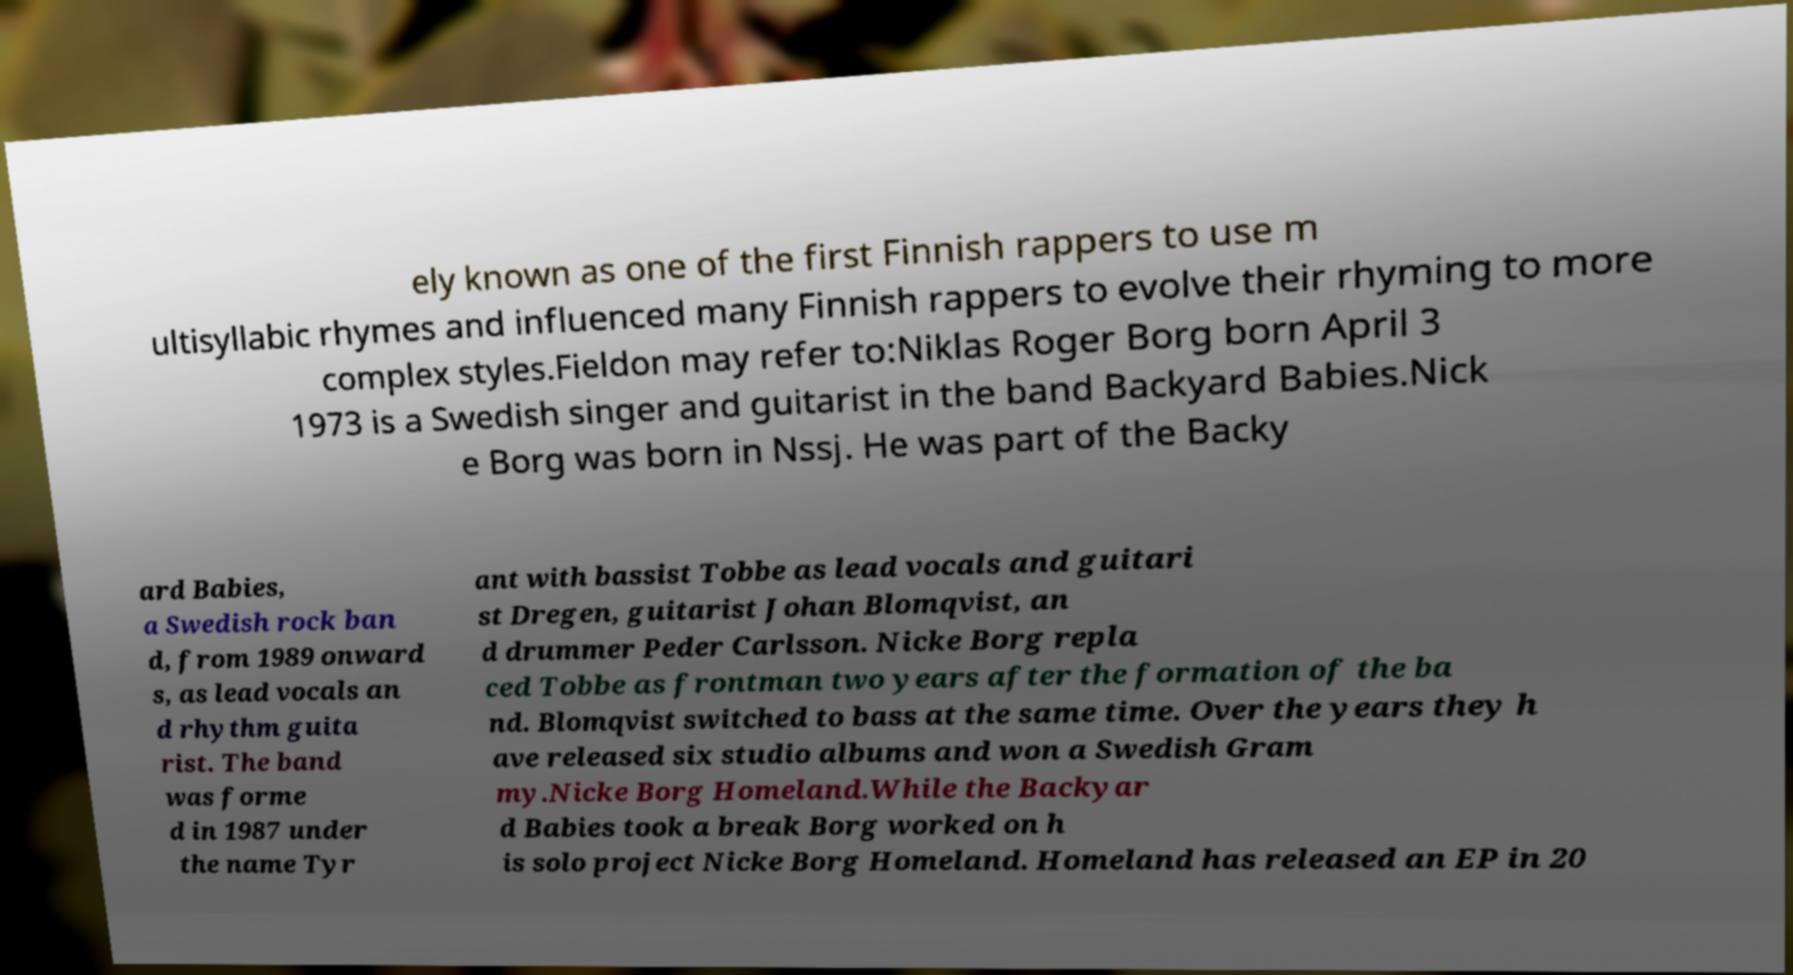Could you extract and type out the text from this image? ely known as one of the first Finnish rappers to use m ultisyllabic rhymes and influenced many Finnish rappers to evolve their rhyming to more complex styles.Fieldon may refer to:Niklas Roger Borg born April 3 1973 is a Swedish singer and guitarist in the band Backyard Babies.Nick e Borg was born in Nssj. He was part of the Backy ard Babies, a Swedish rock ban d, from 1989 onward s, as lead vocals an d rhythm guita rist. The band was forme d in 1987 under the name Tyr ant with bassist Tobbe as lead vocals and guitari st Dregen, guitarist Johan Blomqvist, an d drummer Peder Carlsson. Nicke Borg repla ced Tobbe as frontman two years after the formation of the ba nd. Blomqvist switched to bass at the same time. Over the years they h ave released six studio albums and won a Swedish Gram my.Nicke Borg Homeland.While the Backyar d Babies took a break Borg worked on h is solo project Nicke Borg Homeland. Homeland has released an EP in 20 